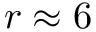<formula> <loc_0><loc_0><loc_500><loc_500>r \approx 6</formula> 